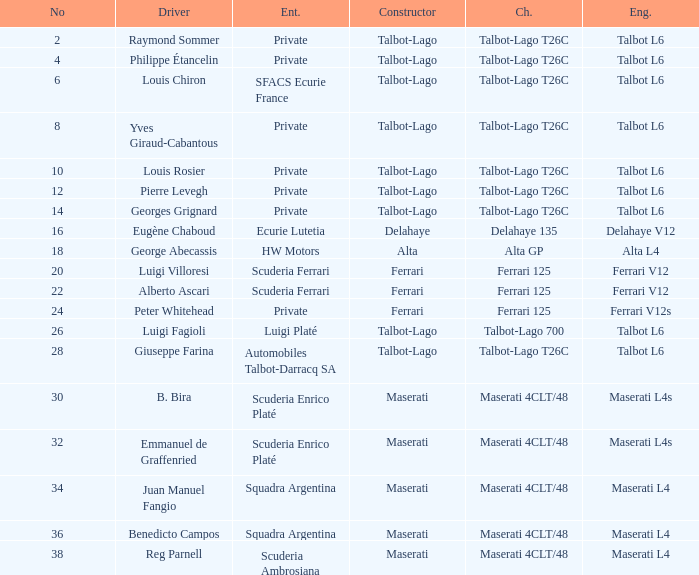Would you be able to parse every entry in this table? {'header': ['No', 'Driver', 'Ent.', 'Constructor', 'Ch.', 'Eng.'], 'rows': [['2', 'Raymond Sommer', 'Private', 'Talbot-Lago', 'Talbot-Lago T26C', 'Talbot L6'], ['4', 'Philippe Étancelin', 'Private', 'Talbot-Lago', 'Talbot-Lago T26C', 'Talbot L6'], ['6', 'Louis Chiron', 'SFACS Ecurie France', 'Talbot-Lago', 'Talbot-Lago T26C', 'Talbot L6'], ['8', 'Yves Giraud-Cabantous', 'Private', 'Talbot-Lago', 'Talbot-Lago T26C', 'Talbot L6'], ['10', 'Louis Rosier', 'Private', 'Talbot-Lago', 'Talbot-Lago T26C', 'Talbot L6'], ['12', 'Pierre Levegh', 'Private', 'Talbot-Lago', 'Talbot-Lago T26C', 'Talbot L6'], ['14', 'Georges Grignard', 'Private', 'Talbot-Lago', 'Talbot-Lago T26C', 'Talbot L6'], ['16', 'Eugène Chaboud', 'Ecurie Lutetia', 'Delahaye', 'Delahaye 135', 'Delahaye V12'], ['18', 'George Abecassis', 'HW Motors', 'Alta', 'Alta GP', 'Alta L4'], ['20', 'Luigi Villoresi', 'Scuderia Ferrari', 'Ferrari', 'Ferrari 125', 'Ferrari V12'], ['22', 'Alberto Ascari', 'Scuderia Ferrari', 'Ferrari', 'Ferrari 125', 'Ferrari V12'], ['24', 'Peter Whitehead', 'Private', 'Ferrari', 'Ferrari 125', 'Ferrari V12s'], ['26', 'Luigi Fagioli', 'Luigi Platé', 'Talbot-Lago', 'Talbot-Lago 700', 'Talbot L6'], ['28', 'Giuseppe Farina', 'Automobiles Talbot-Darracq SA', 'Talbot-Lago', 'Talbot-Lago T26C', 'Talbot L6'], ['30', 'B. Bira', 'Scuderia Enrico Platé', 'Maserati', 'Maserati 4CLT/48', 'Maserati L4s'], ['32', 'Emmanuel de Graffenried', 'Scuderia Enrico Platé', 'Maserati', 'Maserati 4CLT/48', 'Maserati L4s'], ['34', 'Juan Manuel Fangio', 'Squadra Argentina', 'Maserati', 'Maserati 4CLT/48', 'Maserati L4'], ['36', 'Benedicto Campos', 'Squadra Argentina', 'Maserati', 'Maserati 4CLT/48', 'Maserati L4'], ['38', 'Reg Parnell', 'Scuderia Ambrosiana', 'Maserati', 'Maserati 4CLT/48', 'Maserati L4']]} Name the chassis for b. bira Maserati 4CLT/48. 